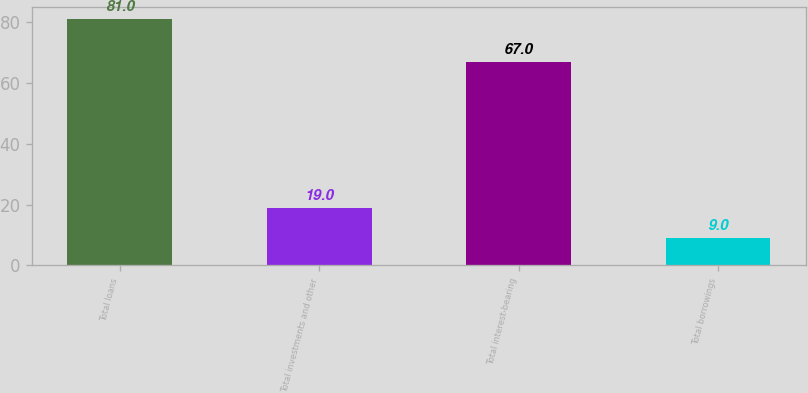Convert chart. <chart><loc_0><loc_0><loc_500><loc_500><bar_chart><fcel>Total loans<fcel>Total investments and other<fcel>Total interest-bearing<fcel>Total borrowings<nl><fcel>81<fcel>19<fcel>67<fcel>9<nl></chart> 